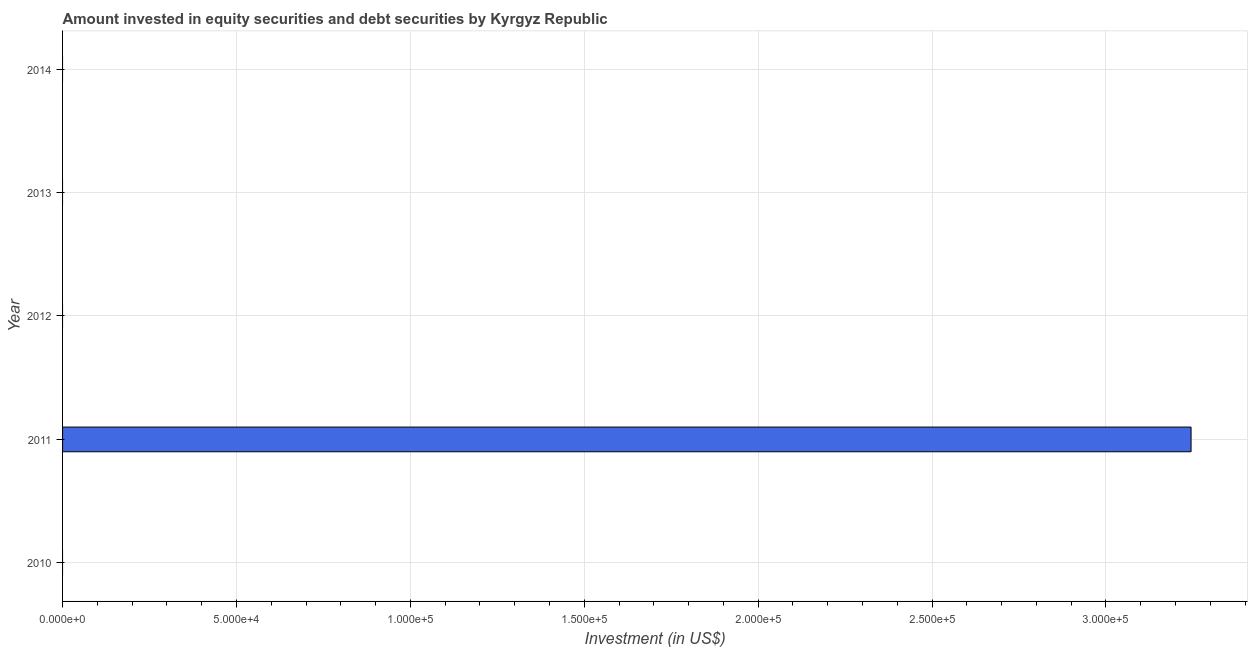What is the title of the graph?
Give a very brief answer. Amount invested in equity securities and debt securities by Kyrgyz Republic. What is the label or title of the X-axis?
Make the answer very short. Investment (in US$). Across all years, what is the maximum portfolio investment?
Make the answer very short. 3.24e+05. Across all years, what is the minimum portfolio investment?
Offer a very short reply. 0. What is the sum of the portfolio investment?
Offer a very short reply. 3.24e+05. What is the average portfolio investment per year?
Offer a very short reply. 6.49e+04. What is the median portfolio investment?
Keep it short and to the point. 0. In how many years, is the portfolio investment greater than 210000 US$?
Provide a succinct answer. 1. What is the difference between the highest and the lowest portfolio investment?
Offer a terse response. 3.24e+05. In how many years, is the portfolio investment greater than the average portfolio investment taken over all years?
Keep it short and to the point. 1. How many years are there in the graph?
Your answer should be very brief. 5. What is the difference between two consecutive major ticks on the X-axis?
Offer a terse response. 5.00e+04. Are the values on the major ticks of X-axis written in scientific E-notation?
Offer a very short reply. Yes. What is the Investment (in US$) in 2011?
Ensure brevity in your answer.  3.24e+05. What is the Investment (in US$) in 2012?
Provide a succinct answer. 0. What is the Investment (in US$) in 2014?
Keep it short and to the point. 0. 